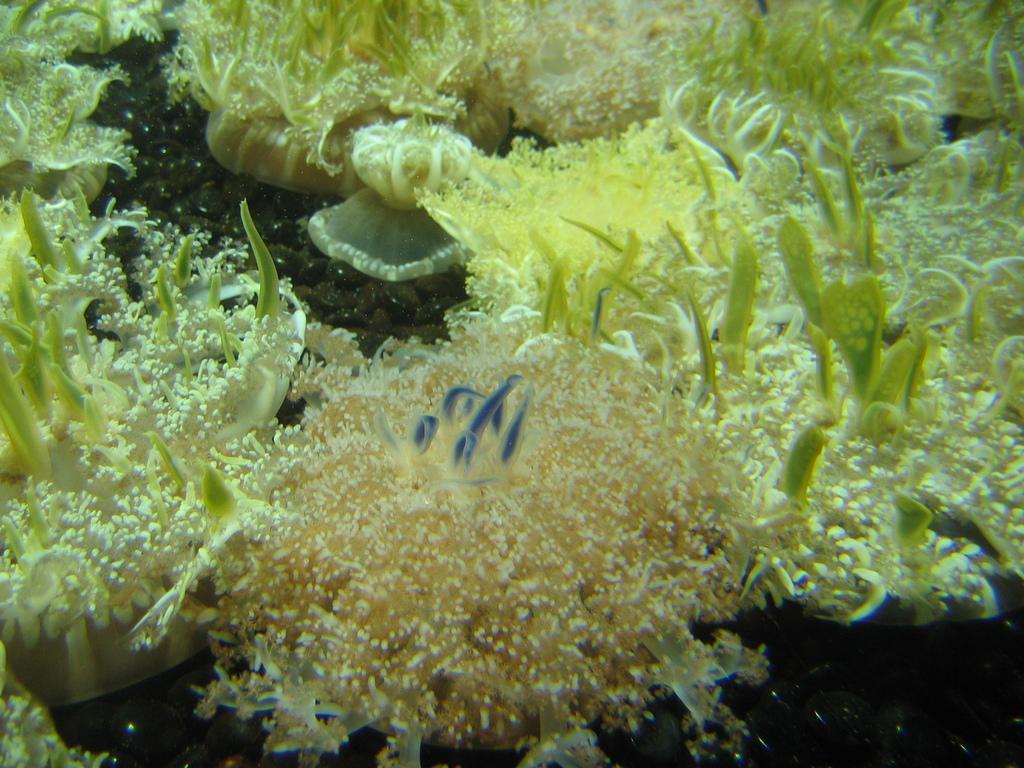Please provide a concise description of this image. In this picture we can see a few corals and underwater plants. 